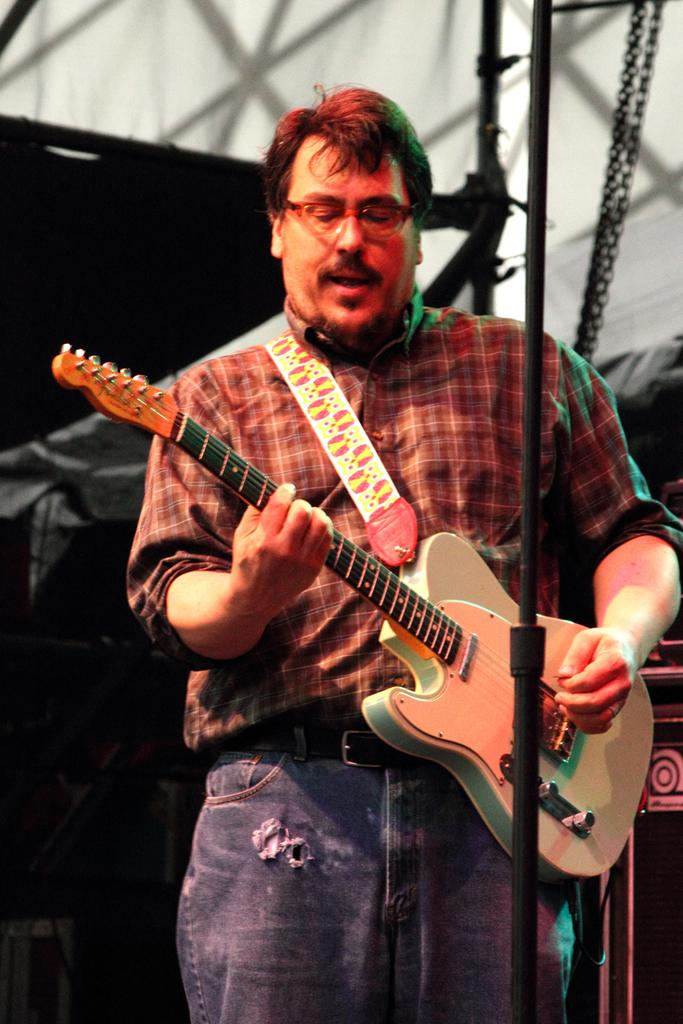Who is the main subject in the image? There is a man in the image. Where is the man located in the image? The man is standing on a stage. What is the man doing in the image? The man is playing a guitar. How many cows are visible in the image? There are no cows present in the image. What letter is the man holding in the image? The man is not holding any letter in the image; he is playing a guitar. 